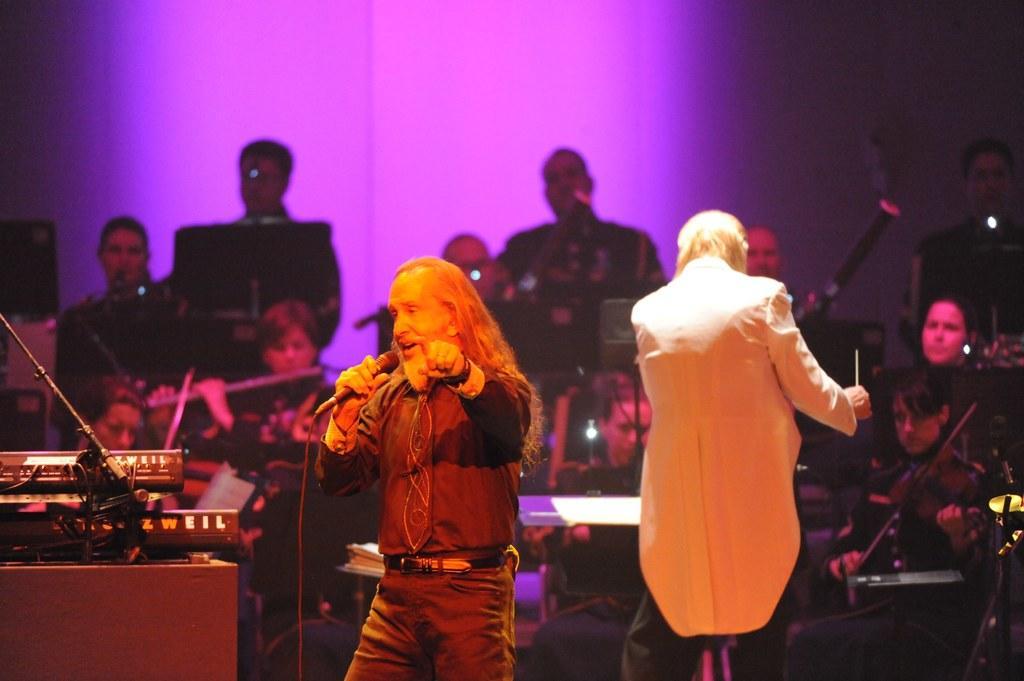How would you summarize this image in a sentence or two? In this picture we can see people playing musical instruments. We can see a man standing with a long hair, holding a mike in his hand and singing. On the left side of the picture we can see devices on the platform. 